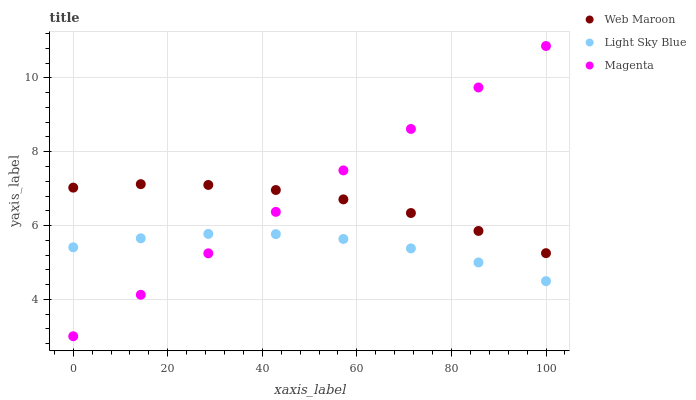Does Light Sky Blue have the minimum area under the curve?
Answer yes or no. Yes. Does Magenta have the maximum area under the curve?
Answer yes or no. Yes. Does Web Maroon have the minimum area under the curve?
Answer yes or no. No. Does Web Maroon have the maximum area under the curve?
Answer yes or no. No. Is Magenta the smoothest?
Answer yes or no. Yes. Is Light Sky Blue the roughest?
Answer yes or no. Yes. Is Web Maroon the smoothest?
Answer yes or no. No. Is Web Maroon the roughest?
Answer yes or no. No. Does Magenta have the lowest value?
Answer yes or no. Yes. Does Light Sky Blue have the lowest value?
Answer yes or no. No. Does Magenta have the highest value?
Answer yes or no. Yes. Does Web Maroon have the highest value?
Answer yes or no. No. Is Light Sky Blue less than Web Maroon?
Answer yes or no. Yes. Is Web Maroon greater than Light Sky Blue?
Answer yes or no. Yes. Does Magenta intersect Light Sky Blue?
Answer yes or no. Yes. Is Magenta less than Light Sky Blue?
Answer yes or no. No. Is Magenta greater than Light Sky Blue?
Answer yes or no. No. Does Light Sky Blue intersect Web Maroon?
Answer yes or no. No. 